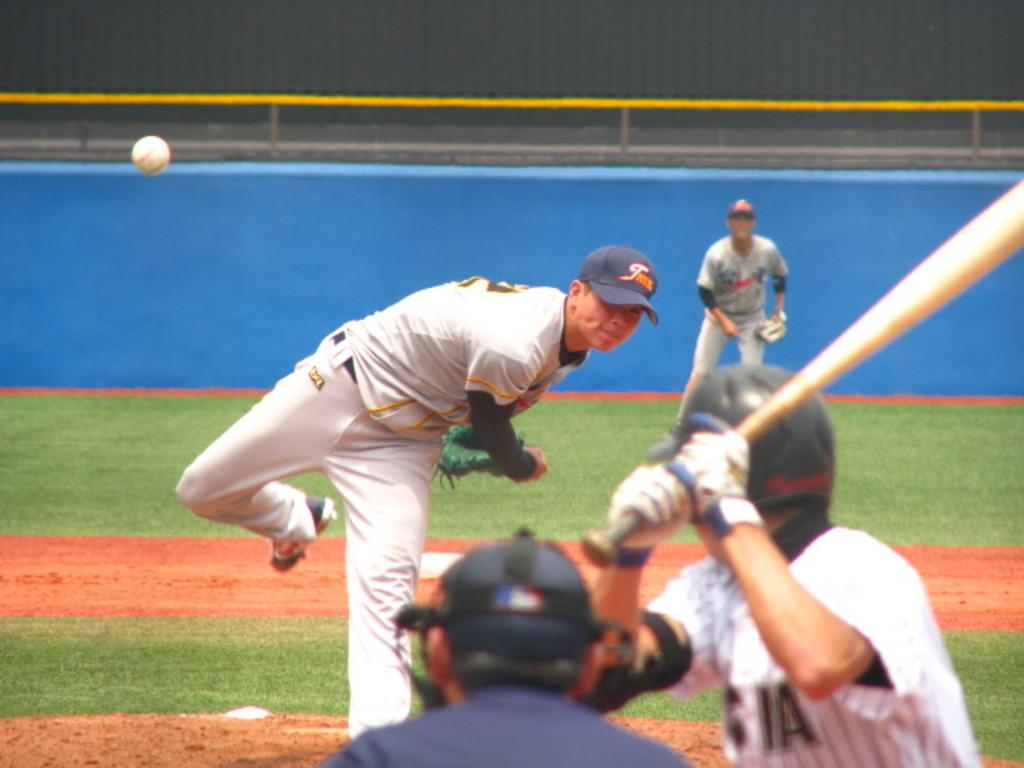What activity are the people in the image engaged in? The people in the image are playing baseball. What type of surface can be seen beneath the players? There is grass visible in the image. What is the purpose of the fencing in the image? The fencing in the image is likely to mark the boundaries of the baseball field or to provide safety for spectators. How many times does the frame jump in the image? There is no frame present in the image, and therefore no such activity can be observed. 